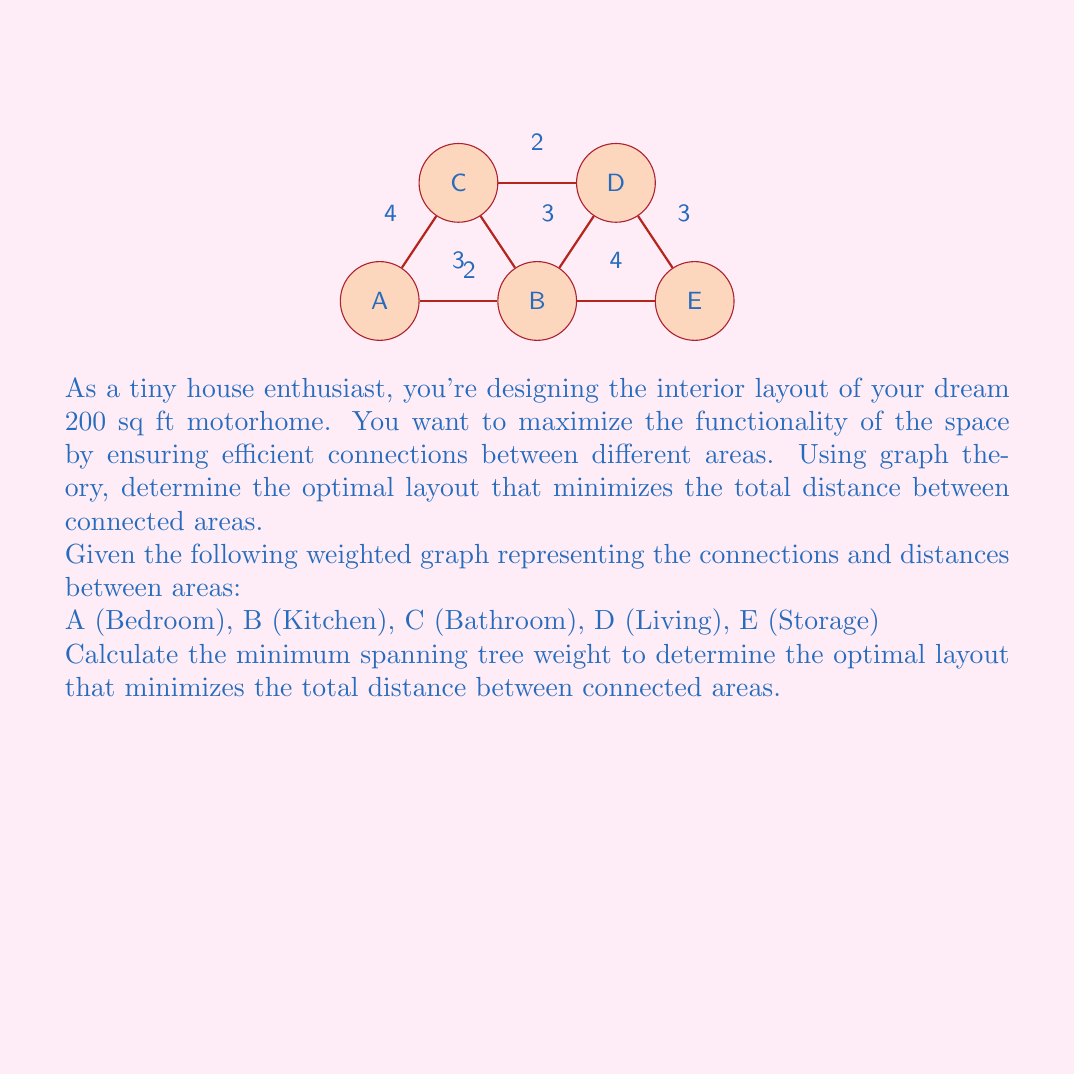Can you answer this question? To find the optimal layout that minimizes the total distance between connected areas, we need to calculate the minimum spanning tree (MST) of the given weighted graph. We'll use Kruskal's algorithm to find the MST:

1. Sort the edges by weight in ascending order:
   (B,C): 2
   (C,D): 2
   (A,B): 3
   (B,D): 3
   (D,E): 3
   (A,C): 4
   (B,E): 4

2. Initialize an empty set for the MST.

3. Iterate through the sorted edges:
   a. (B,C): 2 - Add to MST
   b. (C,D): 2 - Add to MST
   c. (A,B): 3 - Add to MST
   d. (B,D): 3 - Skip (creates a cycle)
   e. (D,E): 3 - Add to MST

4. Stop as we have included all vertices in the MST.

5. Calculate the total weight of the MST:
   $$\text{Total weight} = 2 + 2 + 3 + 3 = 10$$

The minimum spanning tree represents the optimal layout that minimizes the total distance between connected areas in the tiny house motorhome.
Answer: 10 